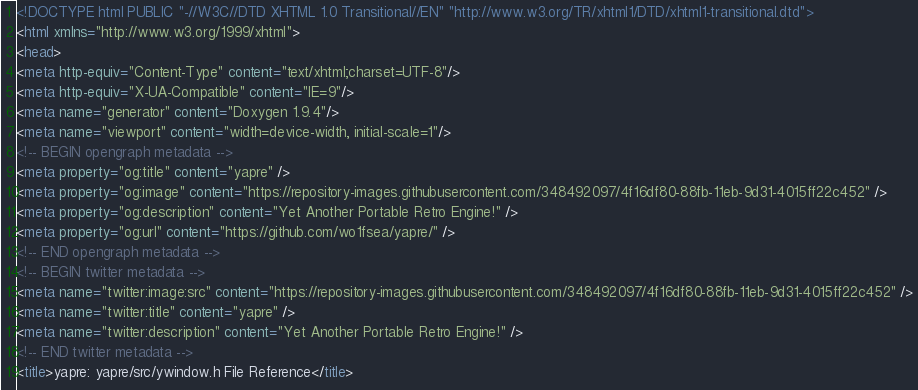Convert code to text. <code><loc_0><loc_0><loc_500><loc_500><_HTML_><!DOCTYPE html PUBLIC "-//W3C//DTD XHTML 1.0 Transitional//EN" "http://www.w3.org/TR/xhtml1/DTD/xhtml1-transitional.dtd">
<html xmlns="http://www.w3.org/1999/xhtml">
<head>
<meta http-equiv="Content-Type" content="text/xhtml;charset=UTF-8"/>
<meta http-equiv="X-UA-Compatible" content="IE=9"/>
<meta name="generator" content="Doxygen 1.9.4"/>
<meta name="viewport" content="width=device-width, initial-scale=1"/>
<!-- BEGIN opengraph metadata -->
<meta property="og:title" content="yapre" />
<meta property="og:image" content="https://repository-images.githubusercontent.com/348492097/4f16df80-88fb-11eb-9d31-4015ff22c452" />
<meta property="og:description" content="Yet Another Portable Retro Engine!" />
<meta property="og:url" content="https://github.com/wo1fsea/yapre/" />
<!-- END opengraph metadata -->
<!-- BEGIN twitter metadata -->
<meta name="twitter:image:src" content="https://repository-images.githubusercontent.com/348492097/4f16df80-88fb-11eb-9d31-4015ff22c452" />
<meta name="twitter:title" content="yapre" />
<meta name="twitter:description" content="Yet Another Portable Retro Engine!" />
<!-- END twitter metadata -->
<title>yapre: yapre/src/ywindow.h File Reference</title></code> 